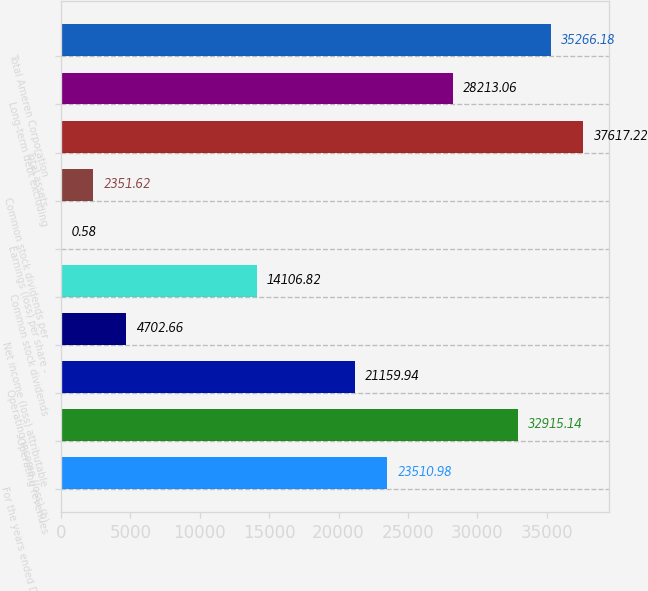<chart> <loc_0><loc_0><loc_500><loc_500><bar_chart><fcel>For the years ended December<fcel>Operating revenues<fcel>Operating income (loss) (b)<fcel>Net income (loss) attributable<fcel>Common stock dividends<fcel>Earnings (loss) per share -<fcel>Common stock dividends per<fcel>Total assets<fcel>Long-term debt excluding<fcel>Total Ameren Corporation<nl><fcel>23511<fcel>32915.1<fcel>21159.9<fcel>4702.66<fcel>14106.8<fcel>0.58<fcel>2351.62<fcel>37617.2<fcel>28213.1<fcel>35266.2<nl></chart> 